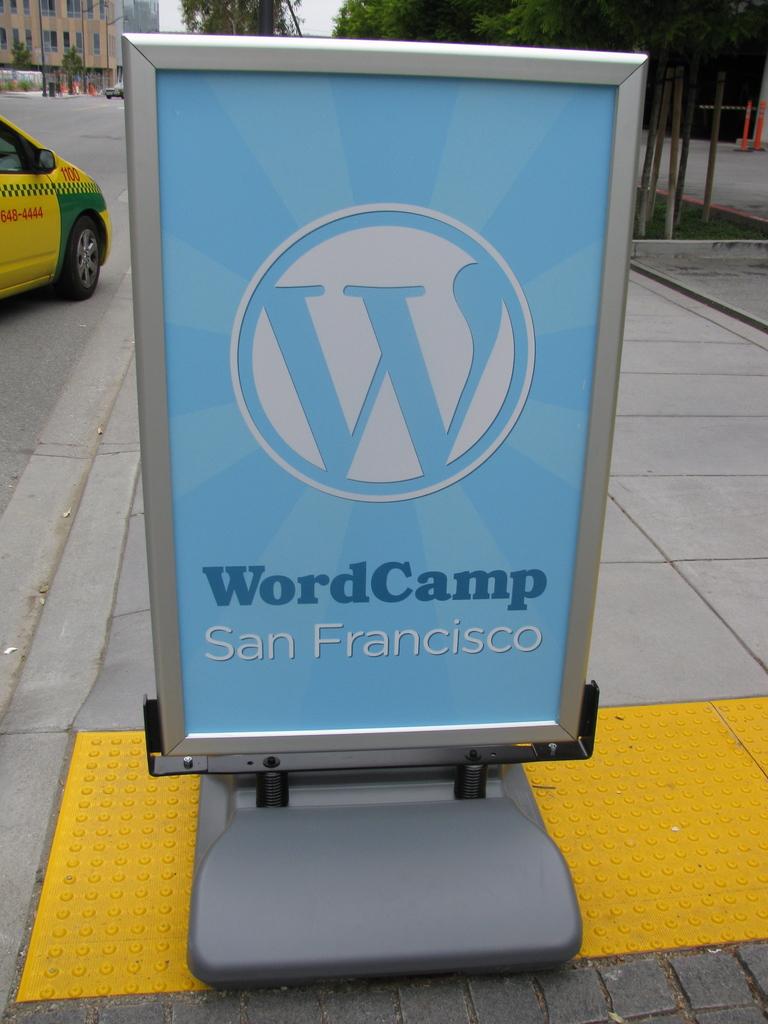Where is this event held?
Your answer should be very brief. San francisco. What event is this?
Provide a succinct answer. Wordcamp. 